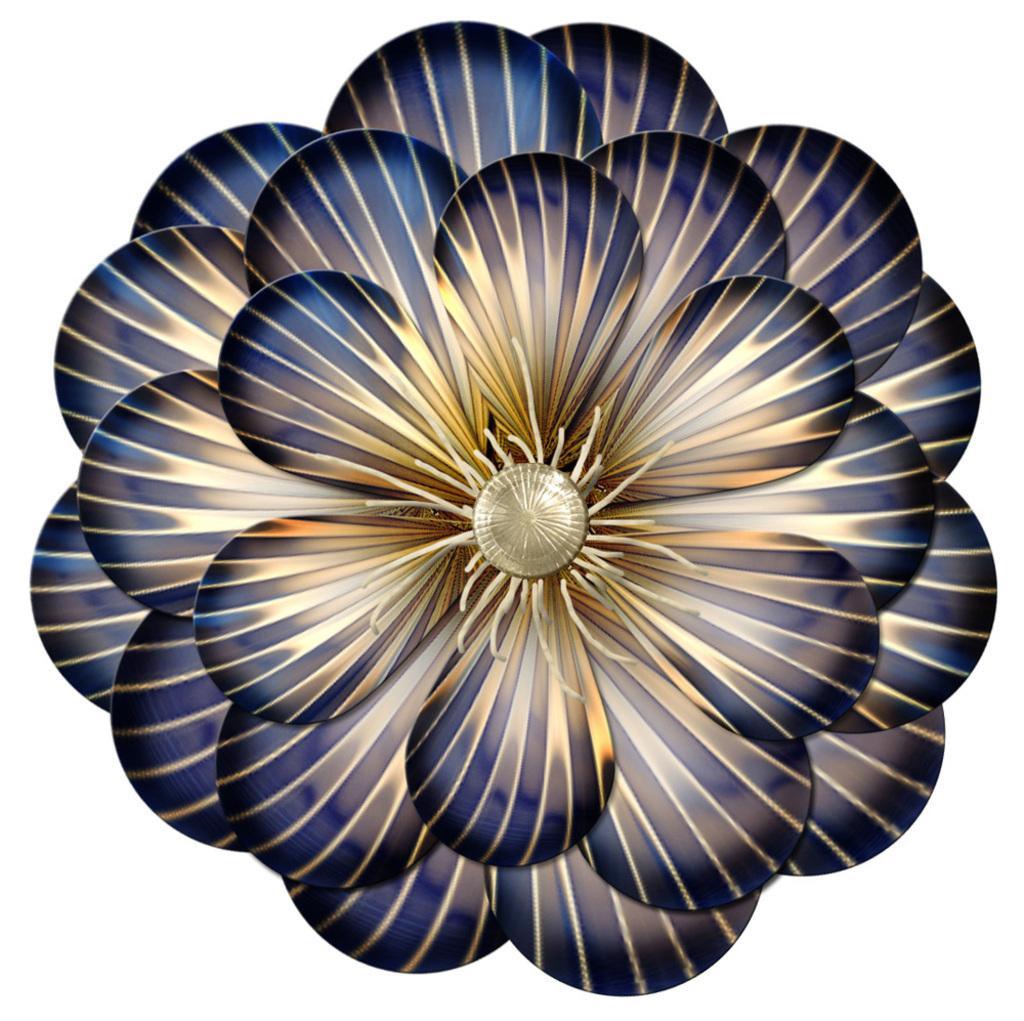Could you give a brief overview of what you see in this image? In this picture I can see the animated image of a flower. 